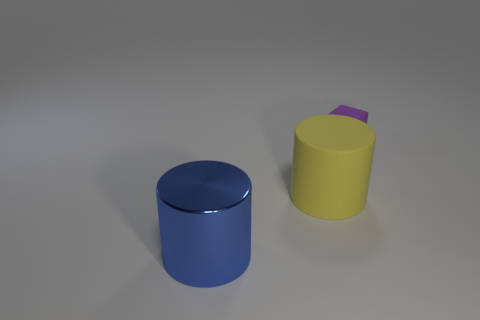Add 1 tiny gray things. How many objects exist? 4 Subtract all green cylinders. Subtract all red cubes. How many cylinders are left? 2 Subtract all cylinders. How many objects are left? 1 Add 3 small rubber cubes. How many small rubber cubes exist? 4 Subtract 0 red cubes. How many objects are left? 3 Subtract all small purple things. Subtract all small purple objects. How many objects are left? 1 Add 2 blue metal cylinders. How many blue metal cylinders are left? 3 